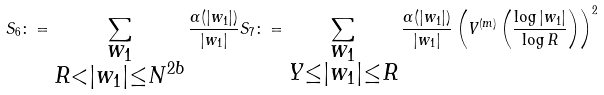Convert formula to latex. <formula><loc_0><loc_0><loc_500><loc_500>S _ { 6 } \colon = \sum _ { \substack { w _ { 1 } \\ R < | w _ { 1 } | \leq N ^ { 2 b } } } \frac { \alpha ( | w _ { 1 } | ) } { | w _ { 1 } | } S _ { 7 } \colon = \sum _ { \substack { w _ { 1 } \\ Y \leq | w _ { 1 } | \leq R } } \frac { \alpha ( | w _ { 1 } | ) } { | w _ { 1 } | } \left ( V ^ { ( m ) } \left ( \frac { \log | w _ { 1 } | } { \log R } \right ) \right ) ^ { 2 }</formula> 